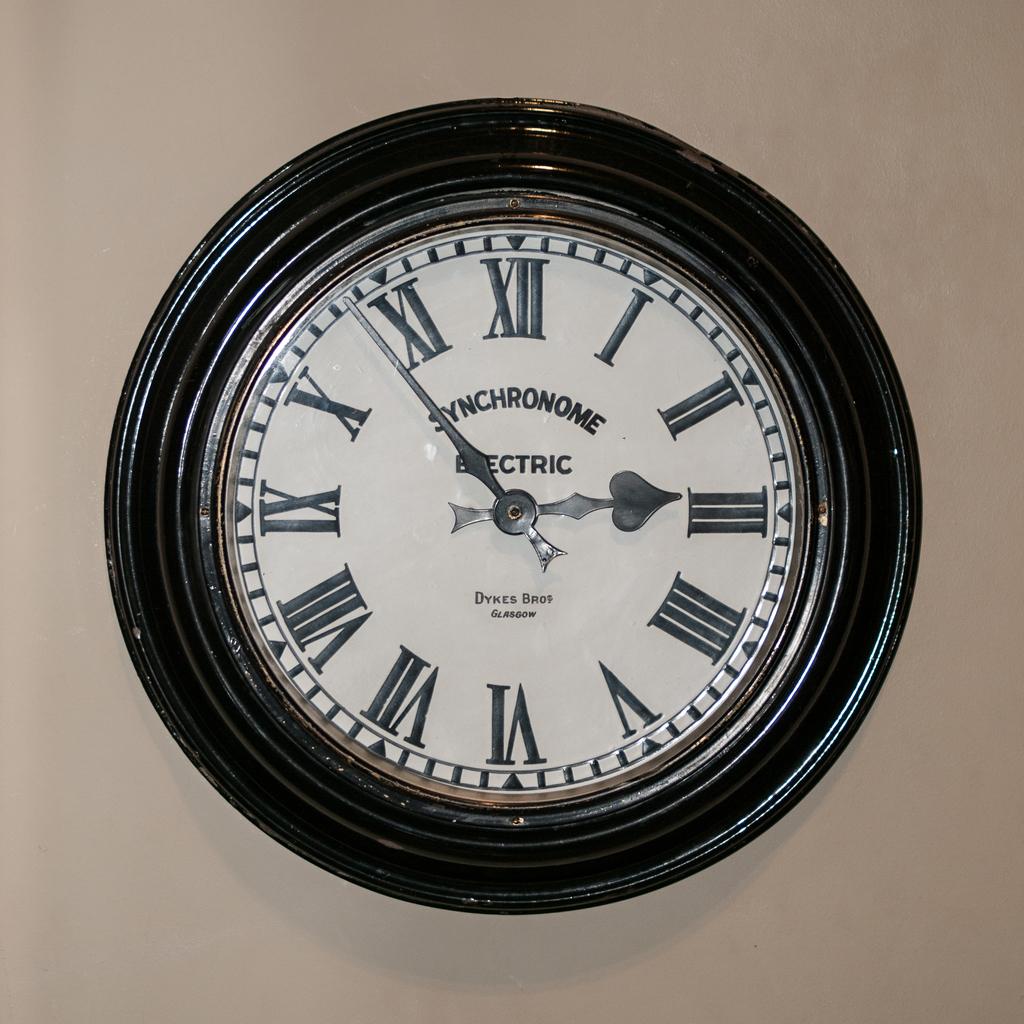What time does the clock claim it is?
Your response must be concise. 2:53. 